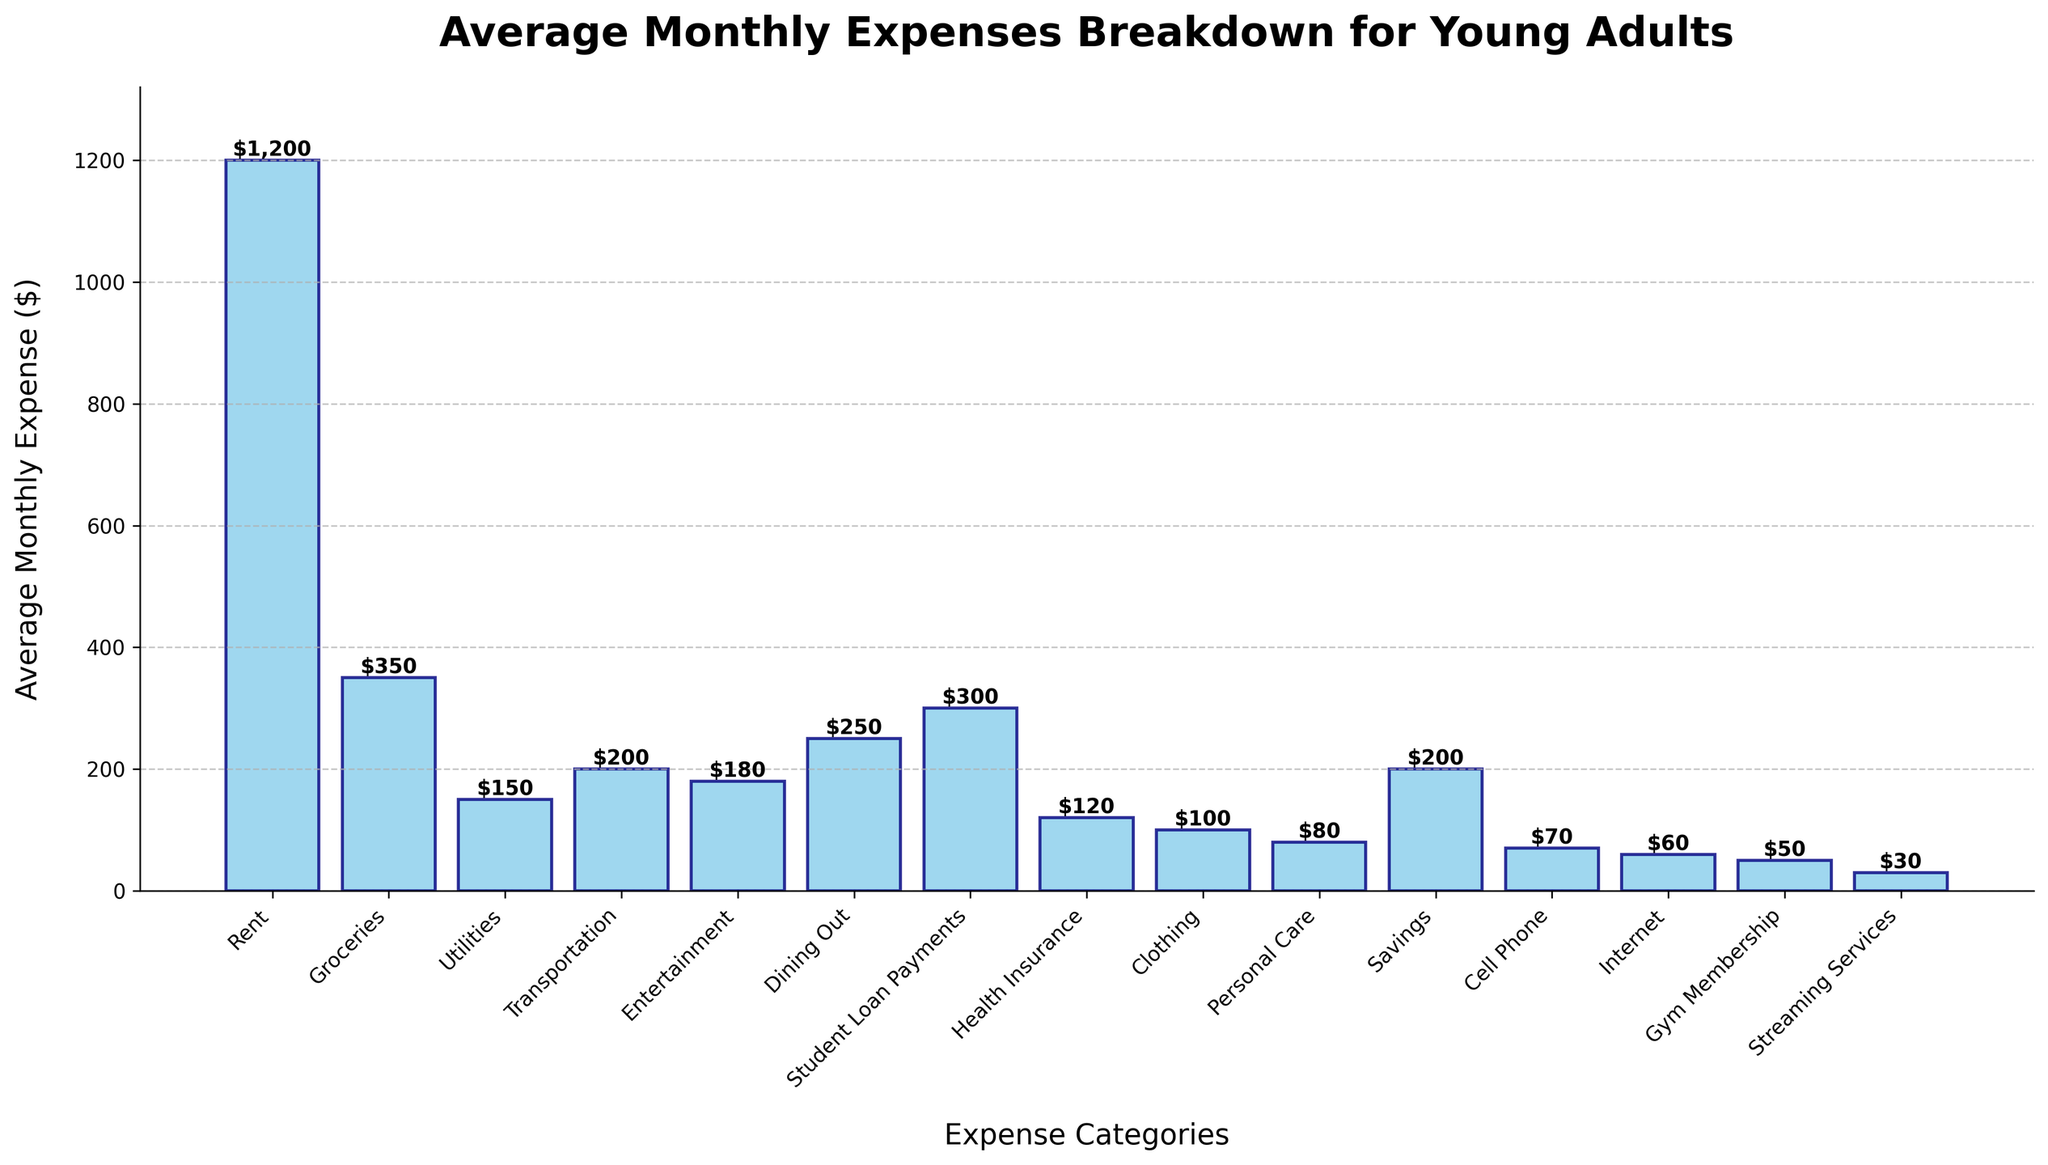Which category has the highest average monthly expense? By looking at the bar chart, the tallest bar represents the highest average monthly expense, which is Rent at $1200.
Answer: Rent How much more do young adults spend on Dining Out compared to Groceries? First, identify the heights of the bars for Dining Out ($250) and Groceries ($350). Then subtract the smaller expense from the larger: $350 - $250.
Answer: $100 What is the total average monthly expense for Utilities, Transportation, and Personal Care combined? Add the average monthly expenses for Utilities ($150), Transportation ($200), and Personal Care ($80): $150 + $200 + $80 = $430.
Answer: $430 Which categories have an average monthly expense that is less than $100? Identify the bars with heights less than $100: Clothing ($100), Personal Care ($80), Cell Phone ($70), Internet ($60), Gym Membership ($50), and Streaming Services ($30).
Answer: Personal Care, Cell Phone, Internet, Gym Membership, Streaming Services By how much is the average expense on Health Insurance less than the expense on Student Loan Payments? First, identify the expenses for Health Insurance ($120) and Student Loan Payments ($300). Then subtract the smaller expense from the larger: $300 - $120.
Answer: $180 What is the total average monthly expense for Entertainment and Savings combined? Add the average monthly expenses for Entertainment ($180) and Savings ($200): $180 + $200 = $380.
Answer: $380 Which category has the smallest average monthly expense? By looking at the bar chart, the shortest bar represents the smallest average monthly expense, which is Streaming Services at $30.
Answer: Streaming Services How does the average monthly expense for Groceries compare to that for Dining Out? By comparing the heights of the bars, Groceries has an expense of $350 while Dining Out has an expense of $250. Therefore, Groceries is more.
Answer: Groceries is more What is the difference between the average monthly expenses for Rent and Health Insurance? Identify the expenses for Rent ($1200) and Health Insurance ($120). Then subtract the smaller expense from the larger: $1200 - $120.
Answer: $1080 Which three categories have the highest average monthly expenses? By checking the heights of the bars, the three tallest bars correspond to Rent ($1200), Groceries ($350), and Dining Out ($250).
Answer: Rent, Groceries, Dining Out 